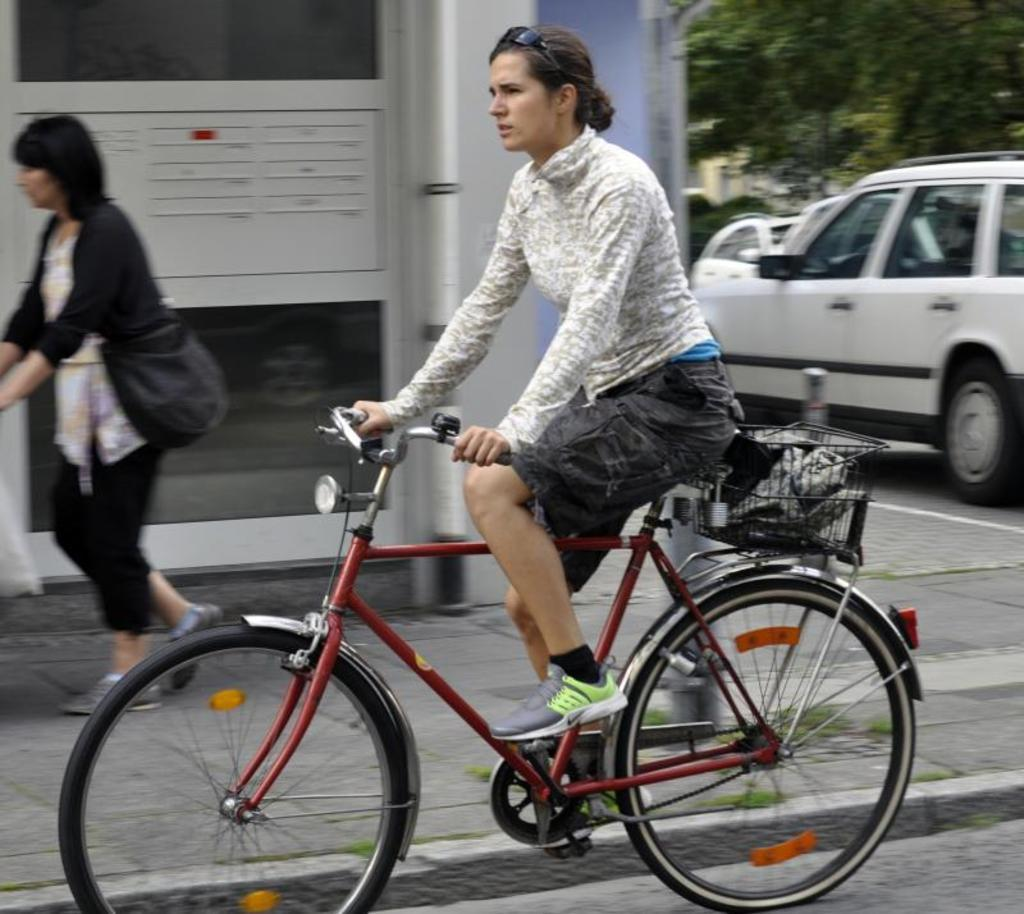Who is the main subject in the image? The main subject in the image is a woman. What is the woman wearing that is unique to her appearance? The woman is wearing goggles. What is the woman doing in the image? The woman is riding a cycle. What can be seen in the background of the image? There is a building, a woman walking, vehicles, and trees visible in the background. What type of guitar is the woman playing while riding the cycle in the image? There is no guitar present in the image; the woman is wearing goggles and riding a cycle. 